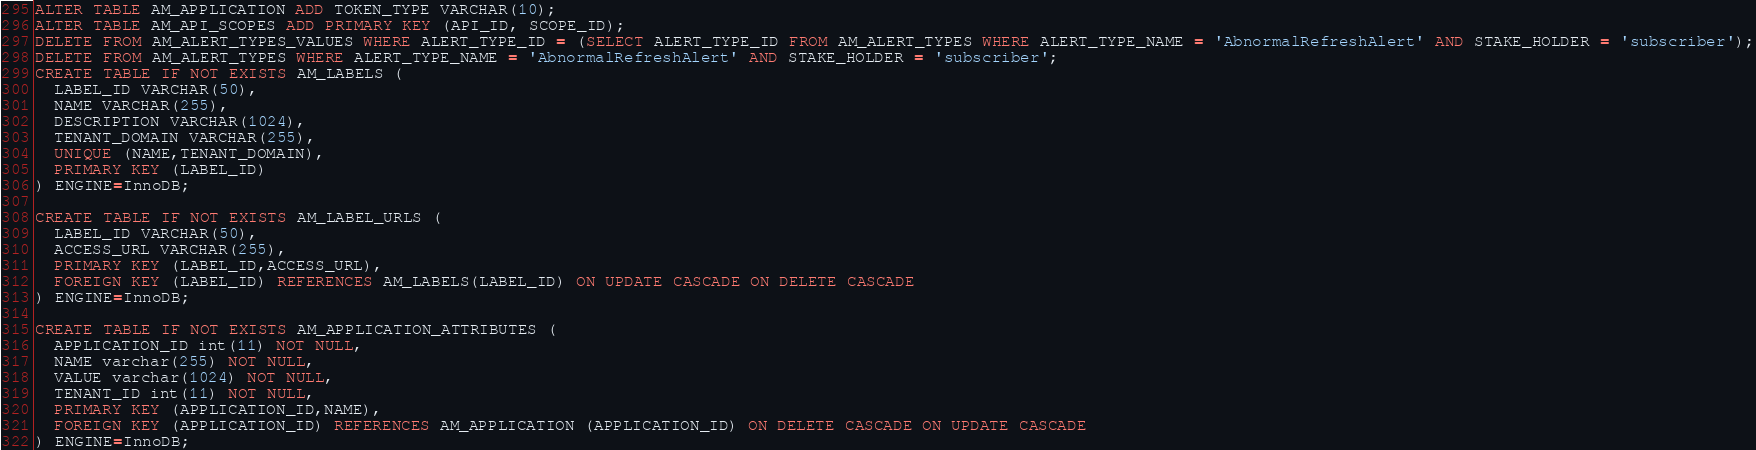Convert code to text. <code><loc_0><loc_0><loc_500><loc_500><_SQL_>ALTER TABLE AM_APPLICATION ADD TOKEN_TYPE VARCHAR(10);
ALTER TABLE AM_API_SCOPES ADD PRIMARY KEY (API_ID, SCOPE_ID);
DELETE FROM AM_ALERT_TYPES_VALUES WHERE ALERT_TYPE_ID = (SELECT ALERT_TYPE_ID FROM AM_ALERT_TYPES WHERE ALERT_TYPE_NAME = 'AbnormalRefreshAlert' AND STAKE_HOLDER = 'subscriber');
DELETE FROM AM_ALERT_TYPES WHERE ALERT_TYPE_NAME = 'AbnormalRefreshAlert' AND STAKE_HOLDER = 'subscriber';
CREATE TABLE IF NOT EXISTS AM_LABELS (
  LABEL_ID VARCHAR(50),
  NAME VARCHAR(255),
  DESCRIPTION VARCHAR(1024),
  TENANT_DOMAIN VARCHAR(255),
  UNIQUE (NAME,TENANT_DOMAIN),
  PRIMARY KEY (LABEL_ID)
) ENGINE=InnoDB;

CREATE TABLE IF NOT EXISTS AM_LABEL_URLS (
  LABEL_ID VARCHAR(50),
  ACCESS_URL VARCHAR(255),
  PRIMARY KEY (LABEL_ID,ACCESS_URL),
  FOREIGN KEY (LABEL_ID) REFERENCES AM_LABELS(LABEL_ID) ON UPDATE CASCADE ON DELETE CASCADE
) ENGINE=InnoDB;

CREATE TABLE IF NOT EXISTS AM_APPLICATION_ATTRIBUTES (
  APPLICATION_ID int(11) NOT NULL,
  NAME varchar(255) NOT NULL,
  VALUE varchar(1024) NOT NULL,
  TENANT_ID int(11) NOT NULL,
  PRIMARY KEY (APPLICATION_ID,NAME),
  FOREIGN KEY (APPLICATION_ID) REFERENCES AM_APPLICATION (APPLICATION_ID) ON DELETE CASCADE ON UPDATE CASCADE
) ENGINE=InnoDB;
</code> 